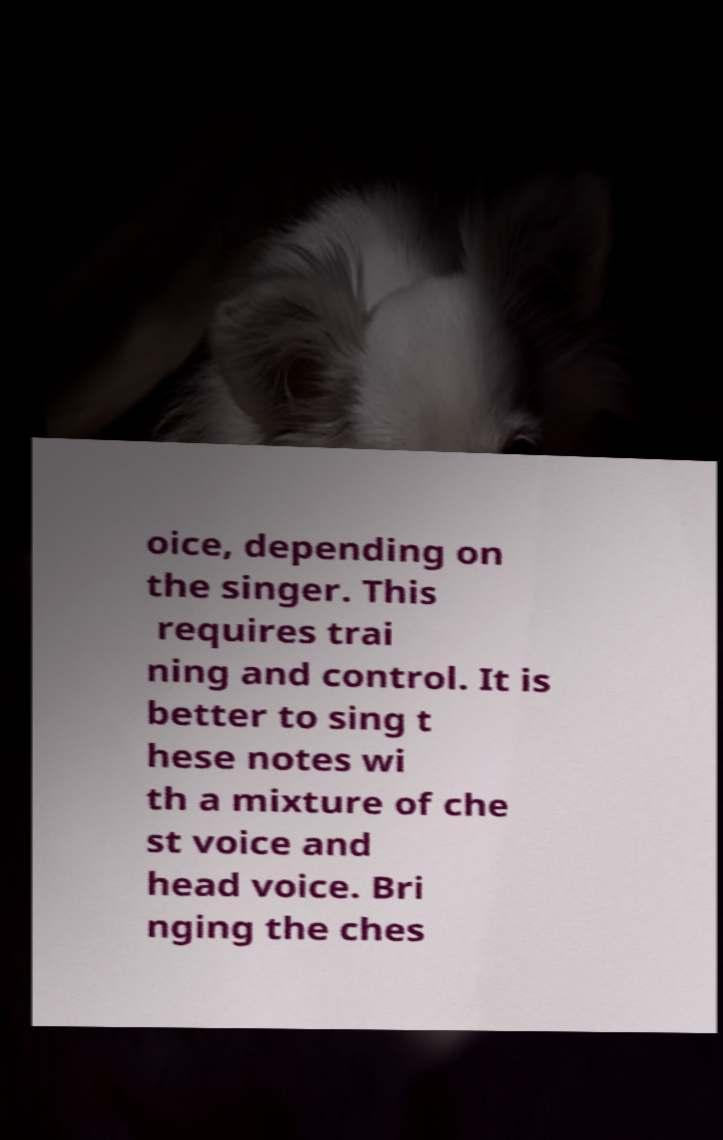There's text embedded in this image that I need extracted. Can you transcribe it verbatim? oice, depending on the singer. This requires trai ning and control. It is better to sing t hese notes wi th a mixture of che st voice and head voice. Bri nging the ches 